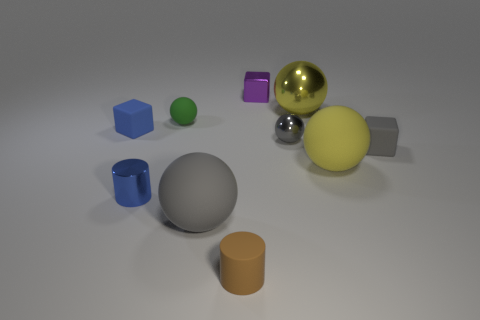There is a big ball that is behind the tiny rubber block that is in front of the blue object that is behind the tiny gray matte thing; what is its material?
Your answer should be compact. Metal. Is the number of blue things on the right side of the large metal thing less than the number of blue matte things?
Provide a succinct answer. Yes. There is a green thing that is the same size as the gray metallic thing; what is its material?
Provide a succinct answer. Rubber. There is a object that is both in front of the small gray metallic object and on the left side of the tiny green matte sphere; what size is it?
Give a very brief answer. Small. What is the size of the gray matte thing that is the same shape as the yellow metal object?
Offer a very short reply. Large. How many things are either big yellow metallic things or tiny objects behind the yellow metallic object?
Keep it short and to the point. 2. The large metal object has what shape?
Your response must be concise. Sphere. There is a small gray object behind the rubber cube that is right of the tiny blue matte thing; what is its shape?
Provide a short and direct response. Sphere. There is a small thing that is the same color as the small metal cylinder; what material is it?
Your answer should be compact. Rubber. There is a large thing that is the same material as the blue cylinder; what color is it?
Ensure brevity in your answer.  Yellow. 